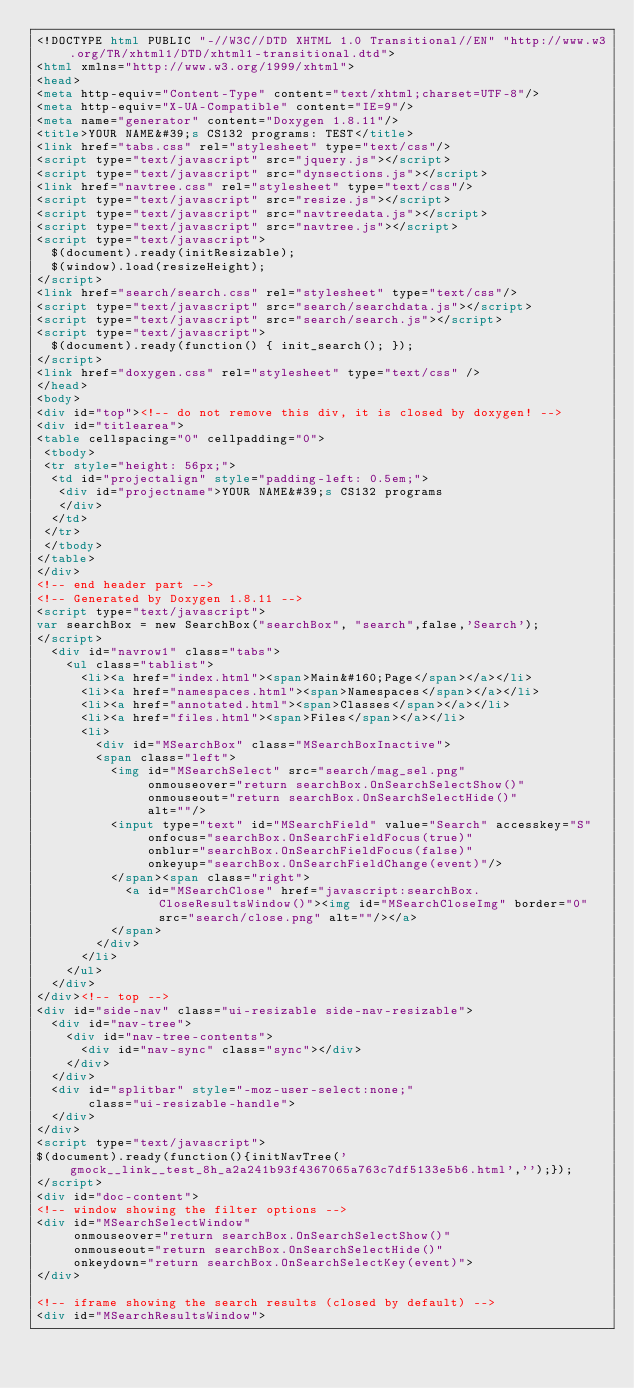Convert code to text. <code><loc_0><loc_0><loc_500><loc_500><_HTML_><!DOCTYPE html PUBLIC "-//W3C//DTD XHTML 1.0 Transitional//EN" "http://www.w3.org/TR/xhtml1/DTD/xhtml1-transitional.dtd">
<html xmlns="http://www.w3.org/1999/xhtml">
<head>
<meta http-equiv="Content-Type" content="text/xhtml;charset=UTF-8"/>
<meta http-equiv="X-UA-Compatible" content="IE=9"/>
<meta name="generator" content="Doxygen 1.8.11"/>
<title>YOUR NAME&#39;s CS132 programs: TEST</title>
<link href="tabs.css" rel="stylesheet" type="text/css"/>
<script type="text/javascript" src="jquery.js"></script>
<script type="text/javascript" src="dynsections.js"></script>
<link href="navtree.css" rel="stylesheet" type="text/css"/>
<script type="text/javascript" src="resize.js"></script>
<script type="text/javascript" src="navtreedata.js"></script>
<script type="text/javascript" src="navtree.js"></script>
<script type="text/javascript">
  $(document).ready(initResizable);
  $(window).load(resizeHeight);
</script>
<link href="search/search.css" rel="stylesheet" type="text/css"/>
<script type="text/javascript" src="search/searchdata.js"></script>
<script type="text/javascript" src="search/search.js"></script>
<script type="text/javascript">
  $(document).ready(function() { init_search(); });
</script>
<link href="doxygen.css" rel="stylesheet" type="text/css" />
</head>
<body>
<div id="top"><!-- do not remove this div, it is closed by doxygen! -->
<div id="titlearea">
<table cellspacing="0" cellpadding="0">
 <tbody>
 <tr style="height: 56px;">
  <td id="projectalign" style="padding-left: 0.5em;">
   <div id="projectname">YOUR NAME&#39;s CS132 programs
   </div>
  </td>
 </tr>
 </tbody>
</table>
</div>
<!-- end header part -->
<!-- Generated by Doxygen 1.8.11 -->
<script type="text/javascript">
var searchBox = new SearchBox("searchBox", "search",false,'Search');
</script>
  <div id="navrow1" class="tabs">
    <ul class="tablist">
      <li><a href="index.html"><span>Main&#160;Page</span></a></li>
      <li><a href="namespaces.html"><span>Namespaces</span></a></li>
      <li><a href="annotated.html"><span>Classes</span></a></li>
      <li><a href="files.html"><span>Files</span></a></li>
      <li>
        <div id="MSearchBox" class="MSearchBoxInactive">
        <span class="left">
          <img id="MSearchSelect" src="search/mag_sel.png"
               onmouseover="return searchBox.OnSearchSelectShow()"
               onmouseout="return searchBox.OnSearchSelectHide()"
               alt=""/>
          <input type="text" id="MSearchField" value="Search" accesskey="S"
               onfocus="searchBox.OnSearchFieldFocus(true)" 
               onblur="searchBox.OnSearchFieldFocus(false)" 
               onkeyup="searchBox.OnSearchFieldChange(event)"/>
          </span><span class="right">
            <a id="MSearchClose" href="javascript:searchBox.CloseResultsWindow()"><img id="MSearchCloseImg" border="0" src="search/close.png" alt=""/></a>
          </span>
        </div>
      </li>
    </ul>
  </div>
</div><!-- top -->
<div id="side-nav" class="ui-resizable side-nav-resizable">
  <div id="nav-tree">
    <div id="nav-tree-contents">
      <div id="nav-sync" class="sync"></div>
    </div>
  </div>
  <div id="splitbar" style="-moz-user-select:none;" 
       class="ui-resizable-handle">
  </div>
</div>
<script type="text/javascript">
$(document).ready(function(){initNavTree('gmock__link__test_8h_a2a241b93f4367065a763c7df5133e5b6.html','');});
</script>
<div id="doc-content">
<!-- window showing the filter options -->
<div id="MSearchSelectWindow"
     onmouseover="return searchBox.OnSearchSelectShow()"
     onmouseout="return searchBox.OnSearchSelectHide()"
     onkeydown="return searchBox.OnSearchSelectKey(event)">
</div>

<!-- iframe showing the search results (closed by default) -->
<div id="MSearchResultsWindow"></code> 